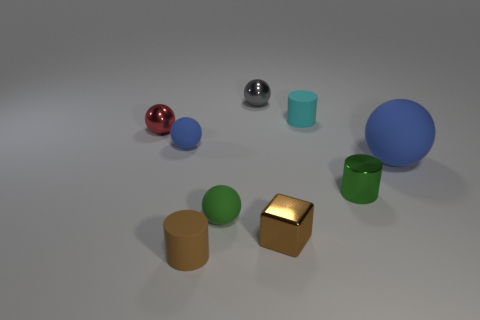Subtract all small metallic spheres. How many spheres are left? 3 Add 1 cyan metallic objects. How many objects exist? 10 Subtract all brown cylinders. How many cylinders are left? 2 Subtract all balls. How many objects are left? 4 Subtract 2 cylinders. How many cylinders are left? 1 Subtract all yellow blocks. How many blue balls are left? 2 Subtract all brown objects. Subtract all tiny blue spheres. How many objects are left? 6 Add 5 gray shiny balls. How many gray shiny balls are left? 6 Add 6 tiny gray things. How many tiny gray things exist? 7 Subtract 0 green blocks. How many objects are left? 9 